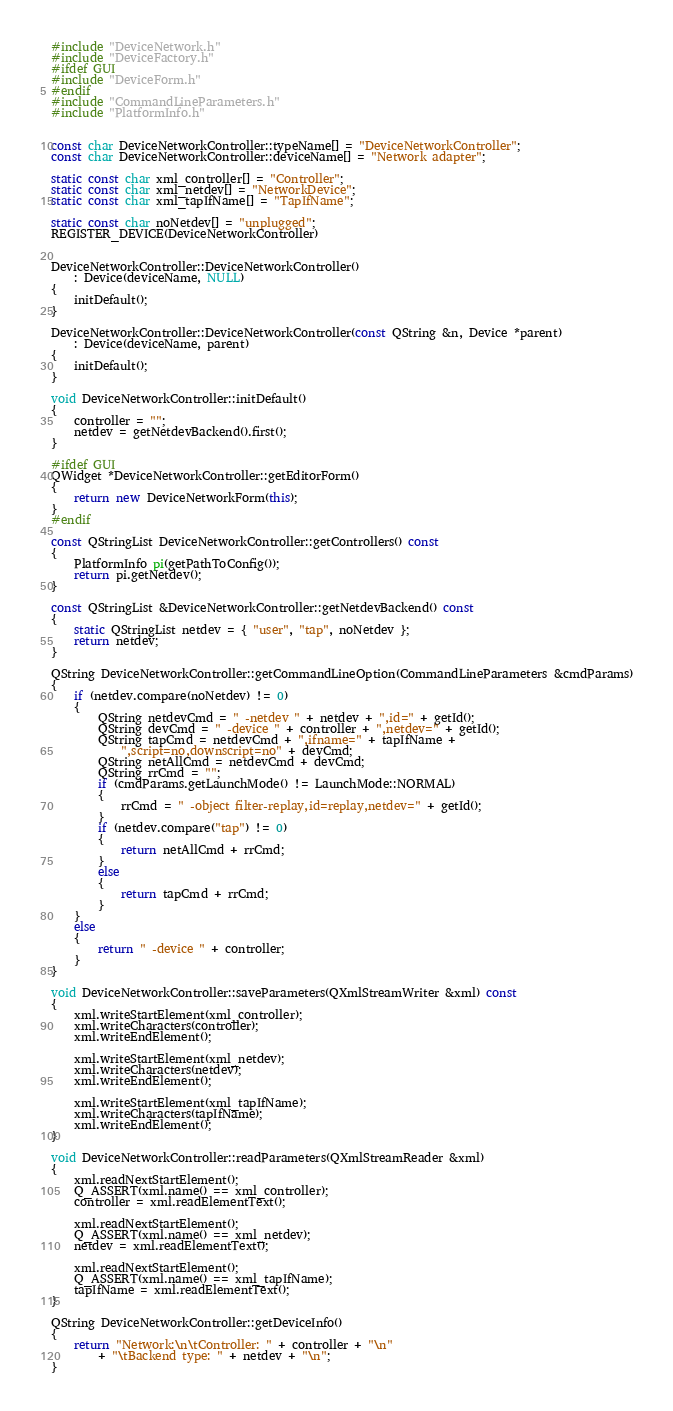<code> <loc_0><loc_0><loc_500><loc_500><_C++_>#include "DeviceNetwork.h"
#include "DeviceFactory.h"
#ifdef GUI
#include "DeviceForm.h"
#endif
#include "CommandLineParameters.h"
#include "PlatformInfo.h"


const char DeviceNetworkController::typeName[] = "DeviceNetworkController";
const char DeviceNetworkController::deviceName[] = "Network adapter";

static const char xml_controller[] = "Controller";
static const char xml_netdev[] = "NetworkDevice";
static const char xml_tapIfName[] = "TapIfName";

static const char noNetdev[] = "unplugged";
REGISTER_DEVICE(DeviceNetworkController)


DeviceNetworkController::DeviceNetworkController()
    : Device(deviceName, NULL)
{
    initDefault();
}

DeviceNetworkController::DeviceNetworkController(const QString &n, Device *parent)
    : Device(deviceName, parent)
{
    initDefault();
}

void DeviceNetworkController::initDefault()
{
    controller = "";
    netdev = getNetdevBackend().first();
}

#ifdef GUI
QWidget *DeviceNetworkController::getEditorForm()
{
    return new DeviceNetworkForm(this);
}
#endif

const QStringList DeviceNetworkController::getControllers() const
{
    PlatformInfo pi(getPathToConfig());
    return pi.getNetdev();
}

const QStringList &DeviceNetworkController::getNetdevBackend() const
{
    static QStringList netdev = { "user", "tap", noNetdev };
    return netdev;
}

QString DeviceNetworkController::getCommandLineOption(CommandLineParameters &cmdParams)
{
    if (netdev.compare(noNetdev) != 0)
    {
        QString netdevCmd = " -netdev " + netdev + ",id=" + getId();
        QString devCmd = " -device " + controller + ",netdev=" + getId();
        QString tapCmd = netdevCmd + ",ifname=" + tapIfName +
            ",script=no,downscript=no" + devCmd;
        QString netAllCmd = netdevCmd + devCmd;
        QString rrCmd = "";
        if (cmdParams.getLaunchMode() != LaunchMode::NORMAL)
        {
            rrCmd = " -object filter-replay,id=replay,netdev=" + getId();
        }
        if (netdev.compare("tap") != 0)
        {
            return netAllCmd + rrCmd;
        }
        else
        {
            return tapCmd + rrCmd;
        }
    }
    else
    {
        return " -device " + controller;
    }
}

void DeviceNetworkController::saveParameters(QXmlStreamWriter &xml) const
{
    xml.writeStartElement(xml_controller);
    xml.writeCharacters(controller);
    xml.writeEndElement();

    xml.writeStartElement(xml_netdev);
    xml.writeCharacters(netdev);
    xml.writeEndElement();

    xml.writeStartElement(xml_tapIfName);
    xml.writeCharacters(tapIfName);
    xml.writeEndElement();
}

void DeviceNetworkController::readParameters(QXmlStreamReader &xml)
{
    xml.readNextStartElement();
    Q_ASSERT(xml.name() == xml_controller);
    controller = xml.readElementText();

    xml.readNextStartElement();
    Q_ASSERT(xml.name() == xml_netdev);
    netdev = xml.readElementText();

    xml.readNextStartElement();
    Q_ASSERT(xml.name() == xml_tapIfName);
    tapIfName = xml.readElementText();
}

QString DeviceNetworkController::getDeviceInfo()
{
    return "Network:\n\tController: " + controller + "\n"
        + "\tBackend type: " + netdev + "\n";
}


</code> 